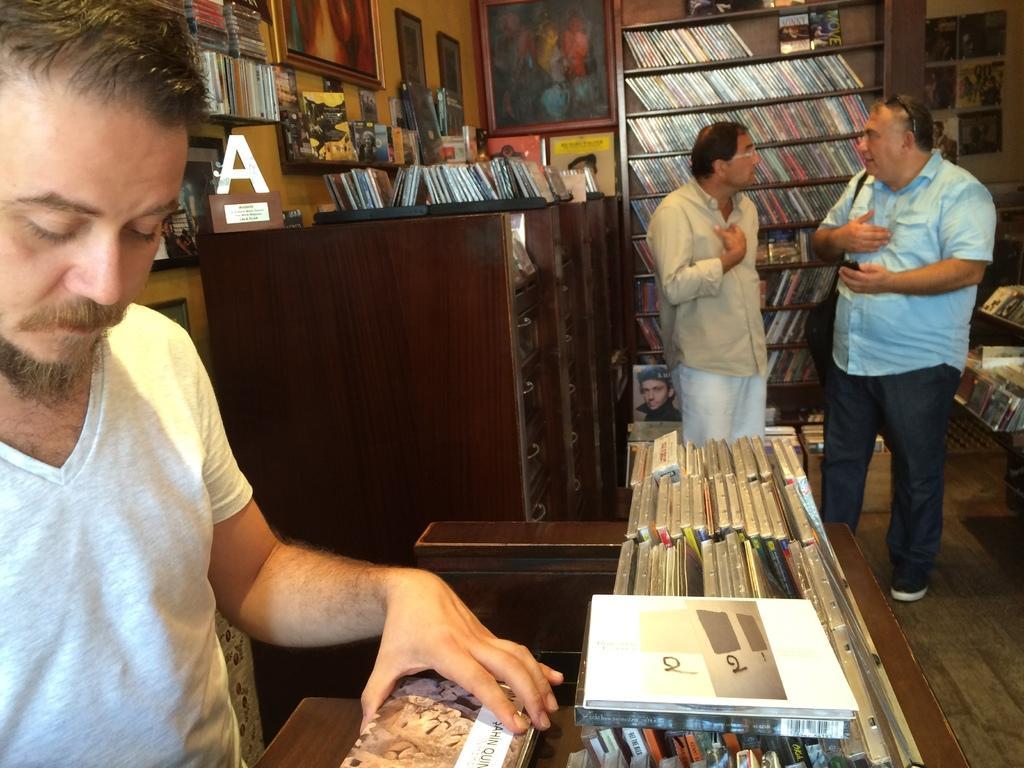Describe this image in one or two sentences. In this image we can see three persons are standing, there are books in a rack, there are books on the table, there are cd boxes on the table, there is a wall and photo frames on it. 